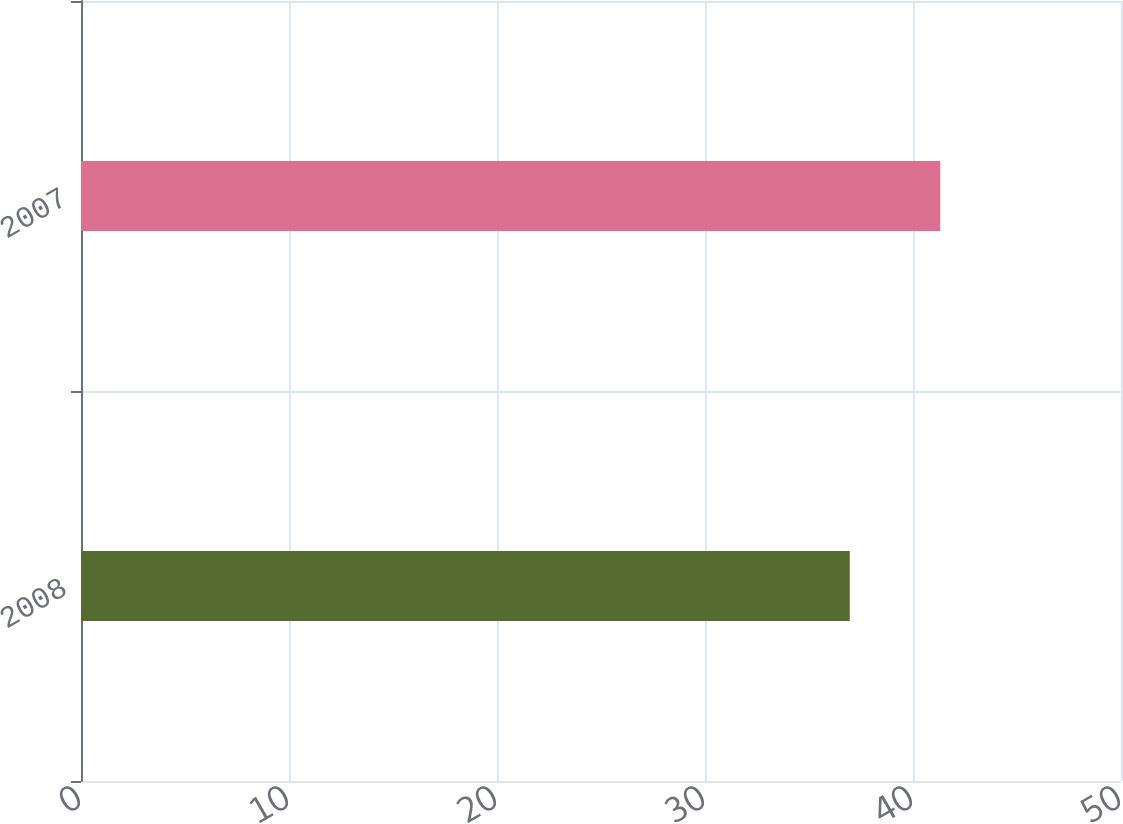<chart> <loc_0><loc_0><loc_500><loc_500><bar_chart><fcel>2008<fcel>2007<nl><fcel>36.96<fcel>41.31<nl></chart> 